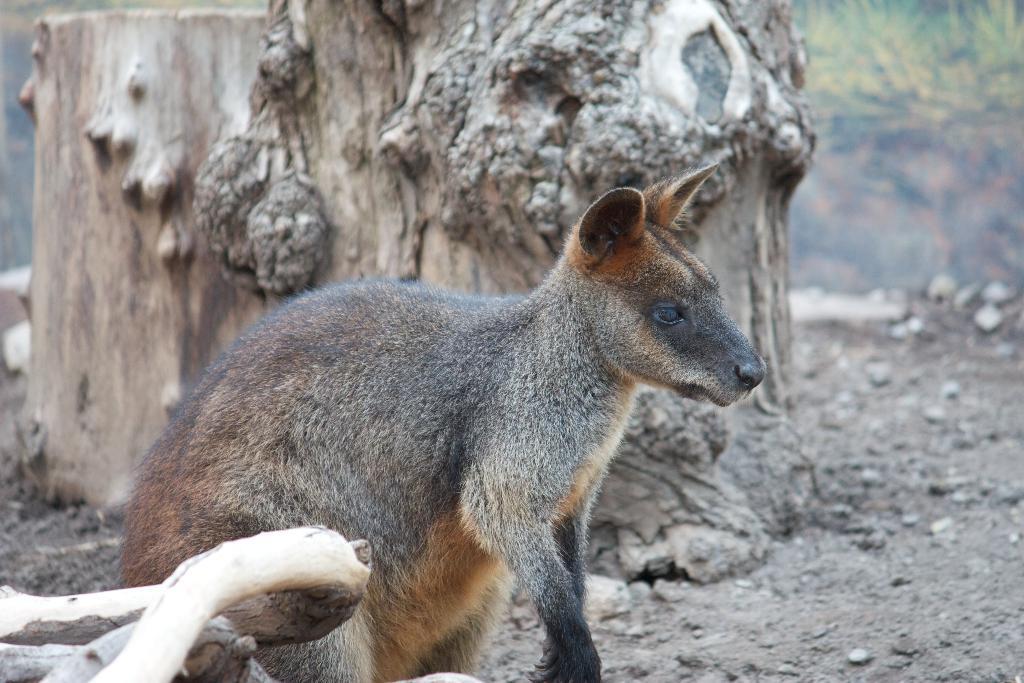Can you describe this image briefly? As we can see in the image there is one animal with black and brown color looking at the ground. Behind the animal there is a tree stem with brown color. 